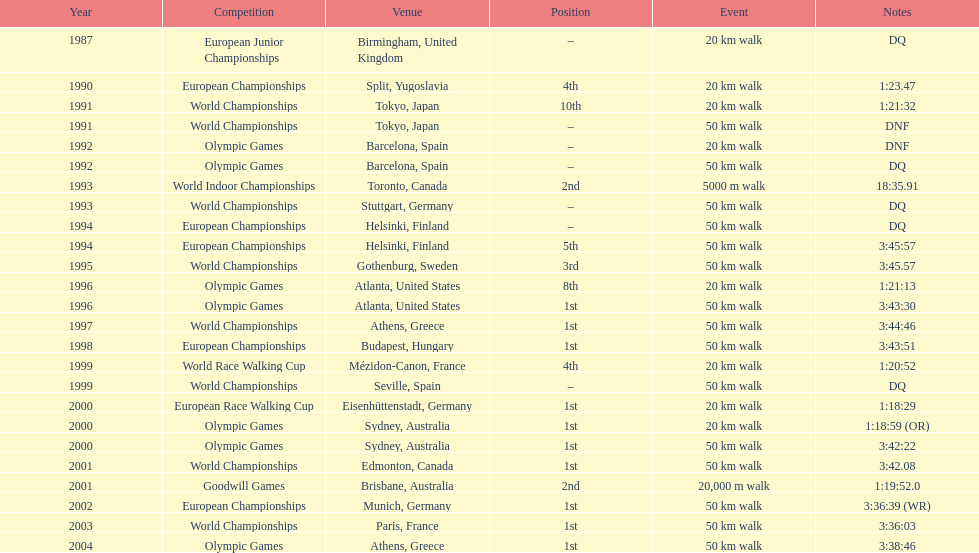In how many occurrences was korzeniowski disqualified from a tournament? 5. 